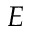Convert formula to latex. <formula><loc_0><loc_0><loc_500><loc_500>E</formula> 